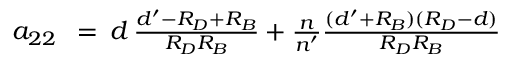<formula> <loc_0><loc_0><loc_500><loc_500>\begin{array} { r l r } { a _ { 2 2 } \, } & = } & { \, d \, { \frac { d ^ { \prime } - R _ { D } + R _ { B } } { R _ { D } R _ { B } } } + { \frac { n } { n ^ { \prime } } } { \frac { ( d ^ { \prime } + R _ { B } ) ( R _ { D } - d ) } { R _ { D } R _ { B } } } } \end{array}</formula> 